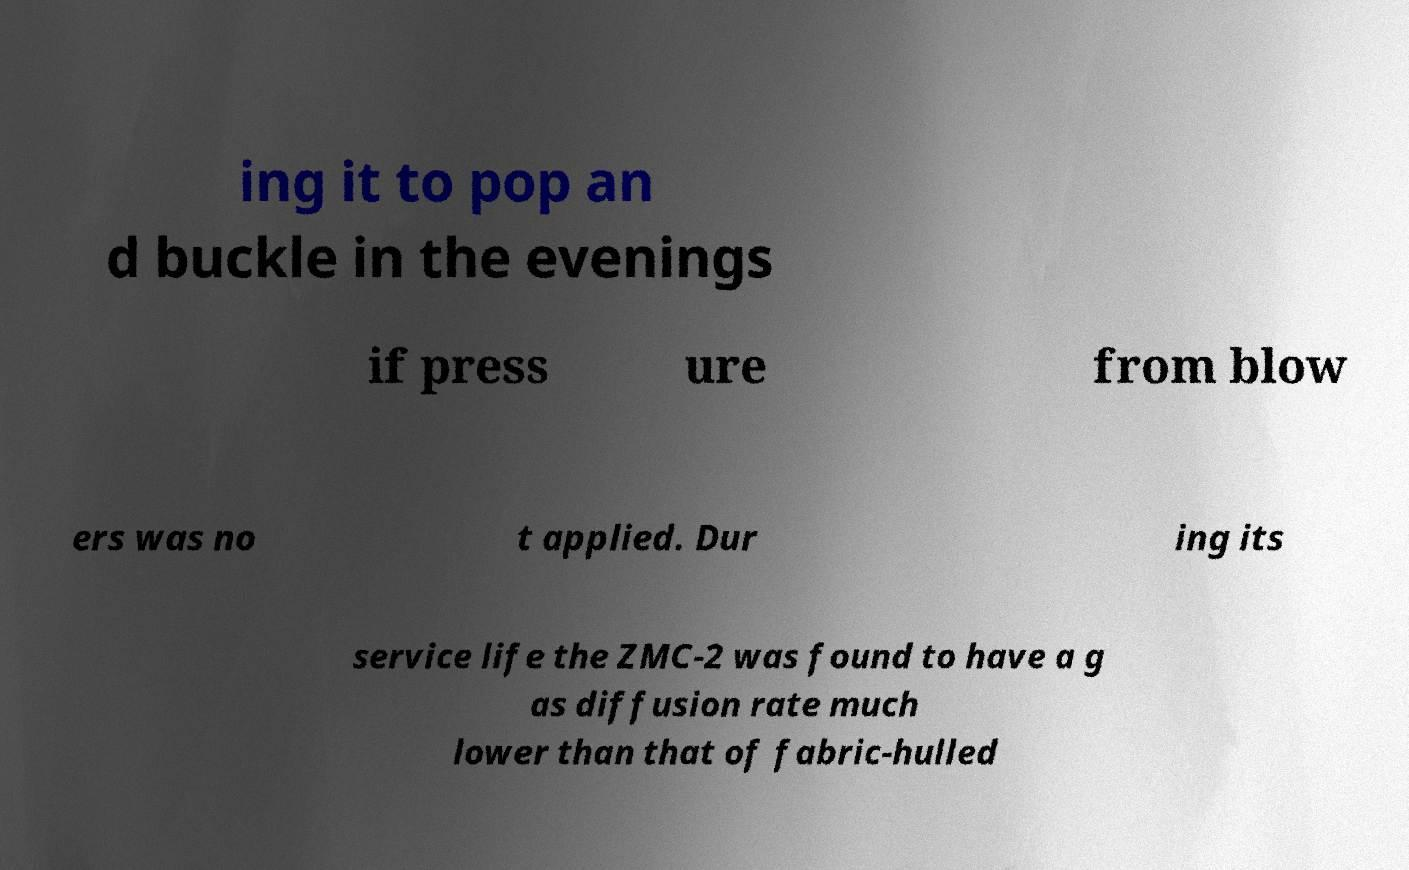Could you extract and type out the text from this image? ing it to pop an d buckle in the evenings if press ure from blow ers was no t applied. Dur ing its service life the ZMC-2 was found to have a g as diffusion rate much lower than that of fabric-hulled 